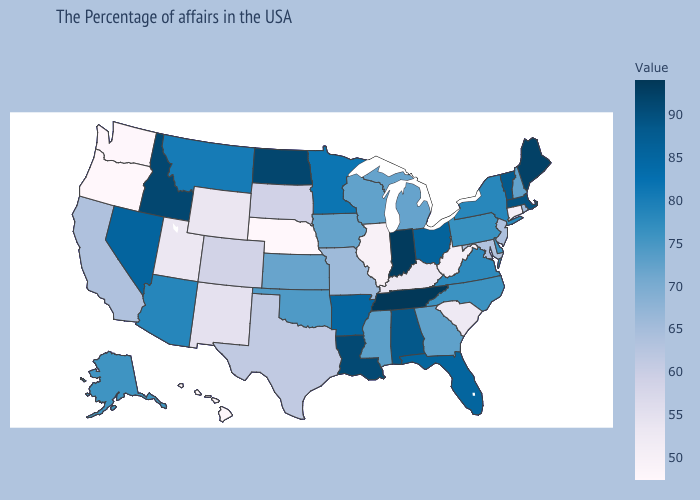Does Maine have the highest value in the Northeast?
Keep it brief. Yes. Does Missouri have the lowest value in the USA?
Short answer required. No. Which states have the lowest value in the USA?
Concise answer only. Nebraska. Does the map have missing data?
Give a very brief answer. No. Does Wyoming have the highest value in the West?
Write a very short answer. No. Which states hav the highest value in the West?
Short answer required. Idaho. 